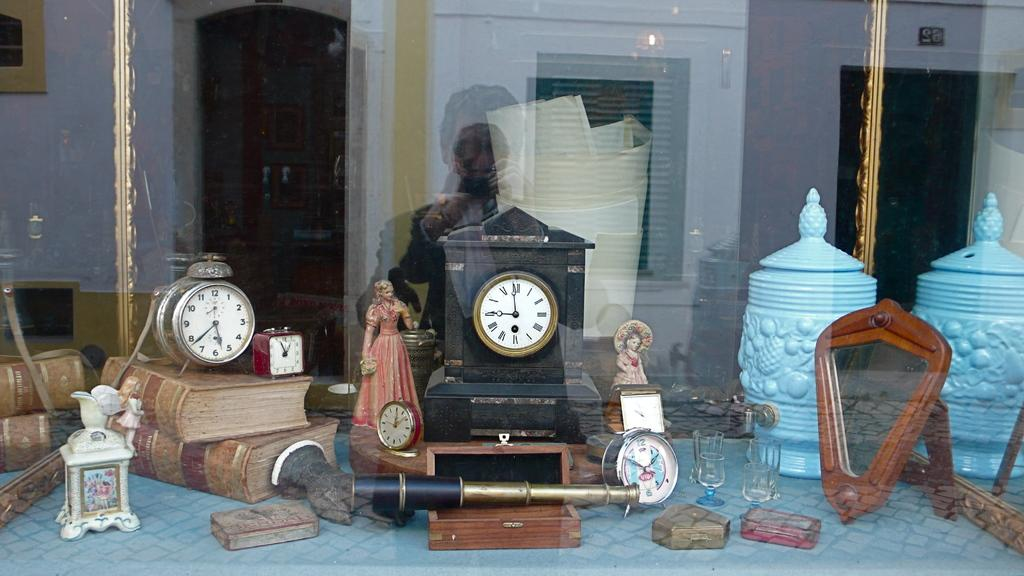<image>
Render a clear and concise summary of the photo. a clock next to another clock with roman numerals and the hand at 9 